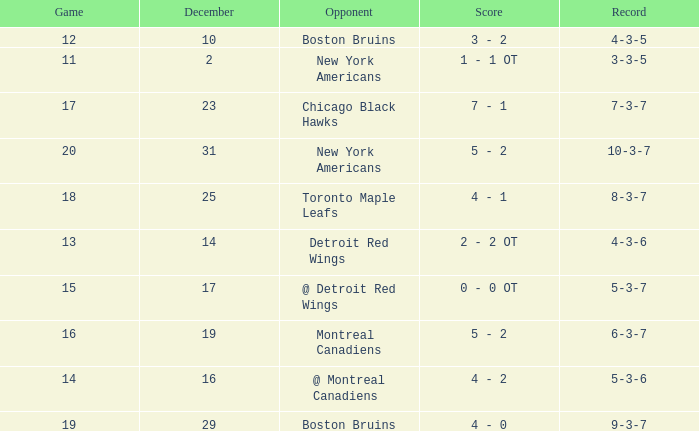Which Score has a December smaller than 14, and a Game of 12? 3 - 2. 